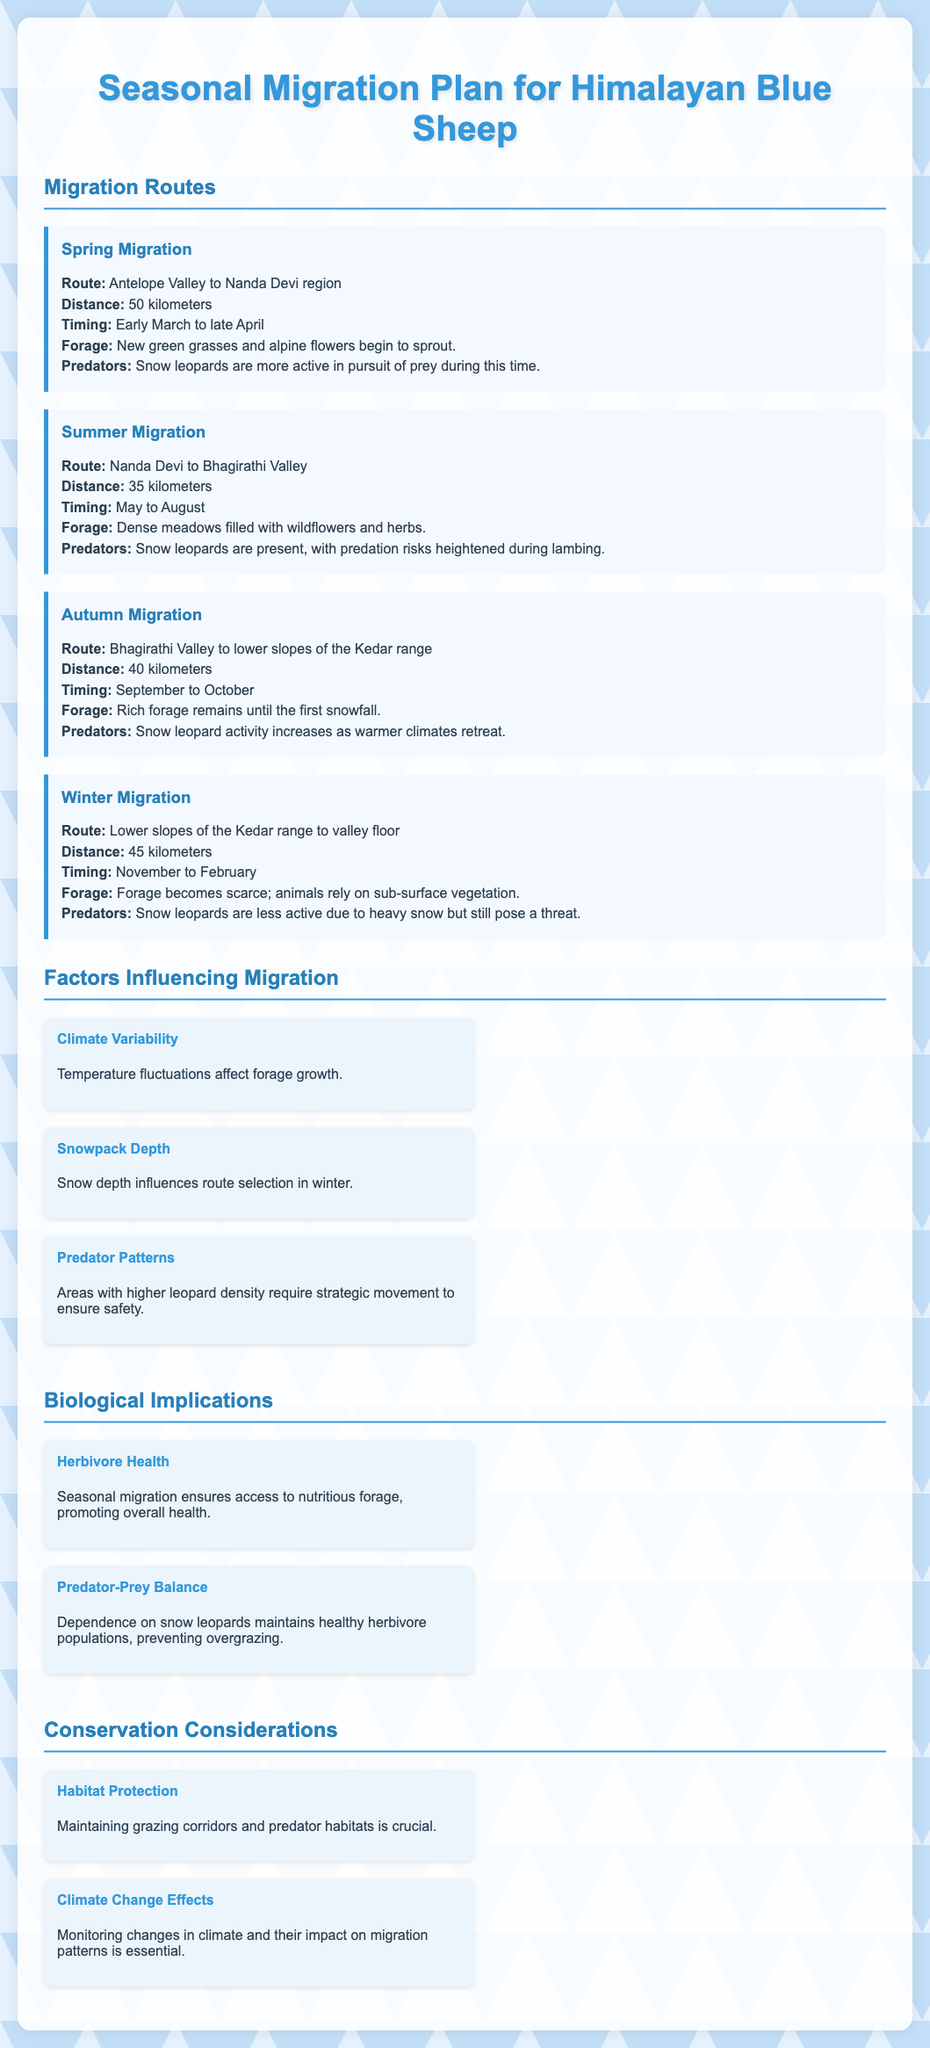what is the timing for spring migration? The document specifies that spring migration occurs from early March to late April.
Answer: early March to late April what is the distance of the summer migration route? According to the document, the summer migration route is 35 kilometers long.
Answer: 35 kilometers what type of forage is available during winter migration? The document states that forage becomes scarce during winter, with reliance on sub-surface vegetation.
Answer: sub-surface vegetation which predator is mentioned in the migration plan? The only predator mentioned in the document is the snow leopard.
Answer: snow leopard how does climate variability influence migration? The document indicates that temperature fluctuations affect forage growth, which influences migration patterns.
Answer: forage growth what are the two main implications of seasonal migration noted? The document outlines herbivore health and predator-prey balance as key implications of seasonal migration.
Answer: herbivore health and predator-prey balance what is one factor that influences migration according to the document? The document mentions that predator patterns influence migration by requiring strategic movement to ensure safety.
Answer: predator patterns what is the route for autumn migration? The document describes the autumn migration route as from Bhagirathi Valley to lower slopes of the Kedar range.
Answer: Bhagirathi Valley to lower slopes of the Kedar range 